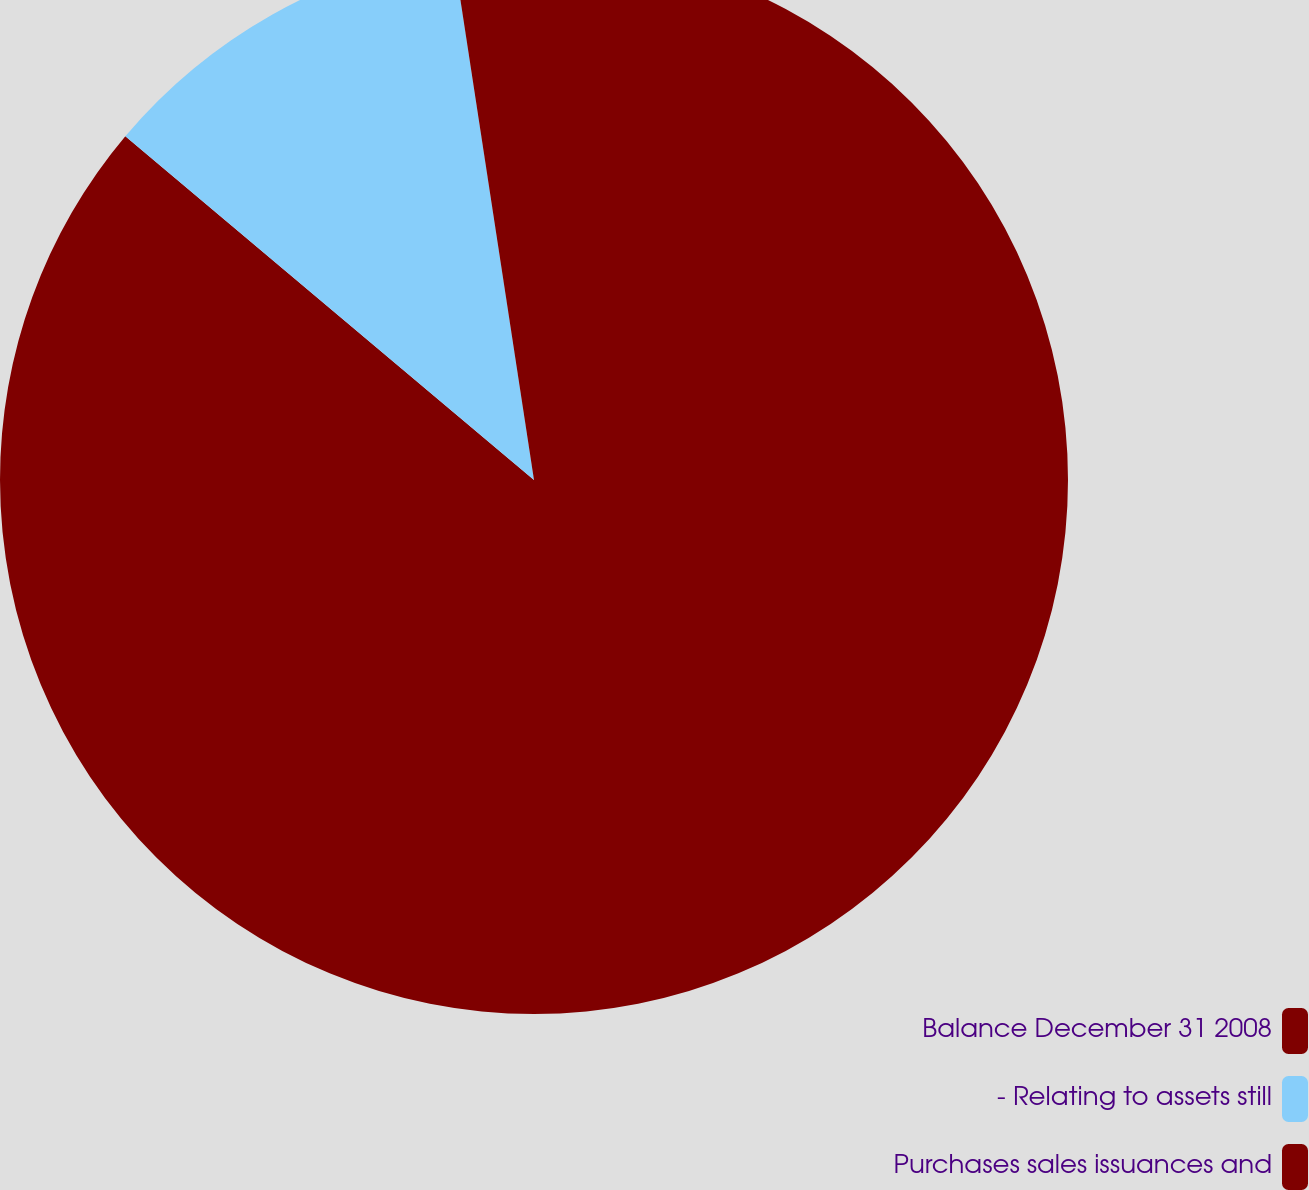Convert chart. <chart><loc_0><loc_0><loc_500><loc_500><pie_chart><fcel>Balance December 31 2008<fcel>- Relating to assets still<fcel>Purchases sales issuances and<nl><fcel>86.13%<fcel>11.45%<fcel>2.42%<nl></chart> 